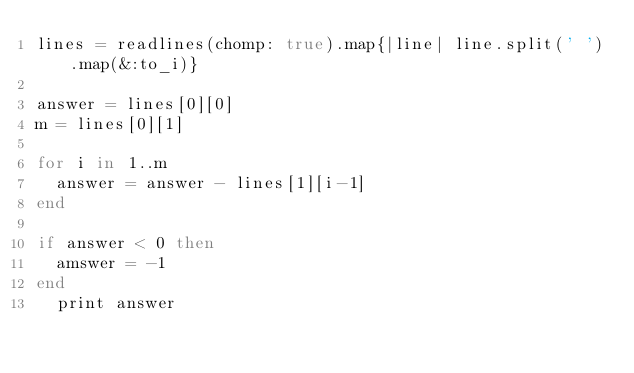<code> <loc_0><loc_0><loc_500><loc_500><_Ruby_>lines = readlines(chomp: true).map{|line| line.split(' ').map(&:to_i)}

answer = lines[0][0]
m = lines[0][1]

for i in 1..m
  answer = answer - lines[1][i-1]
end

if answer < 0 then
  amswer = -1
end
  print answer</code> 